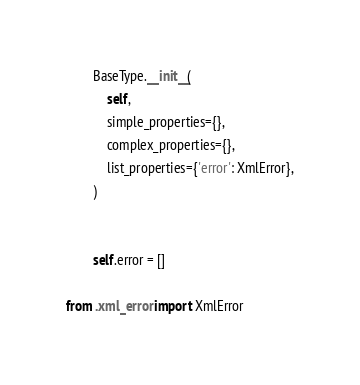<code> <loc_0><loc_0><loc_500><loc_500><_Python_>        BaseType.__init__(
            self,
            simple_properties={},
            complex_properties={},
            list_properties={'error': XmlError},
        )
        
        
        self.error = []

from .xml_error import XmlError

</code> 